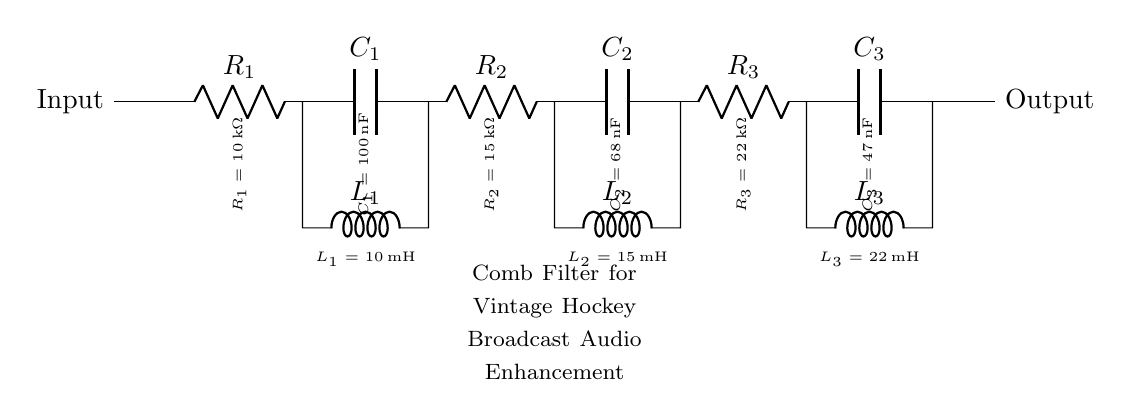What type of filter is represented in this circuit? The circuit is a comb filter, indicated by the label at the bottom of the diagram. A comb filter is characterized by its configuration of resistors, capacitors, and inductors which create constructive and destructive interference at specific frequencies.
Answer: Comb filter How many stages are in this comb filter? The circuit diagram shows three distinct stages where each stage contains a resistor, capacitor, and an inductor. This is evident from the layout and connections of components in the circuit.
Answer: Three What is the value of the first resistor in the circuit? Looking at the label on the circuit, the first resistor, R1, is marked with a value of 10 kilohms. This is a descriptive question based on the visual information presented in the circuit diagram.
Answer: 10 kilohms What is the purpose of the capacitors in this comb filter? The capacitors in this filter create additional phase shifting and resonance characteristics for particular frequencies, contributing to the comb filtering effect. This is inferred from their placement in the circuit, alongside resistors and inductors, which are essential for shaping frequency responses.
Answer: Frequency shaping How do the inductors affect the audio signals in this circuit? Inductors in this circuit work in conjunction with resistors and capacitors to create a low-pass filter effect at certain frequencies, allowing only specific audio frequencies to pass through while attenuating others. This is understood by analyzing their position within the filter stages and their role in tuning the filter response.
Answer: Low-pass filtering What is the value of the second inductor in the circuit? By examining the diagram again, the second inductor, L2, is labeled with a value of 15 millihenries. Identifying component values is straightforward as they are listed next to each component in the diagram.
Answer: 15 millihenries 